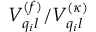Convert formula to latex. <formula><loc_0><loc_0><loc_500><loc_500>V _ { q _ { i } l } ^ { ( f ) } / { V } _ { q _ { i } l } ^ { ( \kappa ) }</formula> 